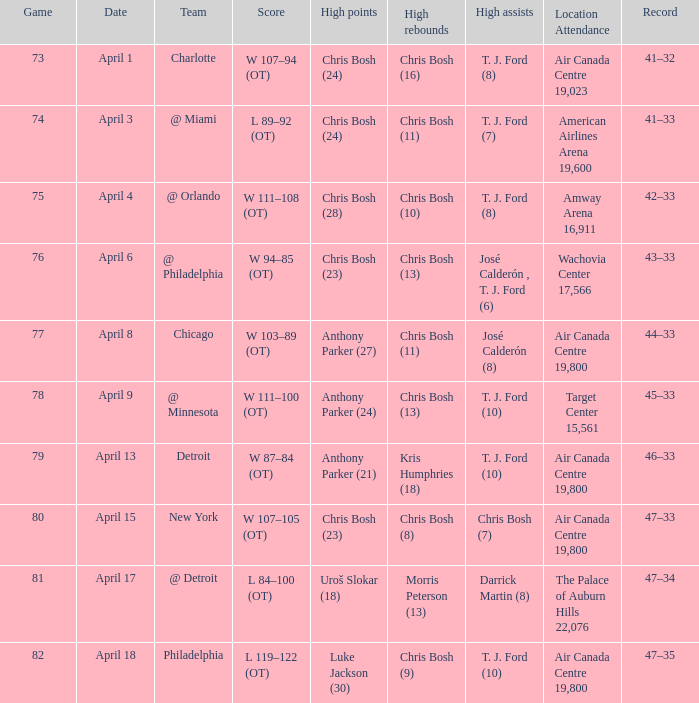What was the score of game 82? L 119–122 (OT). 